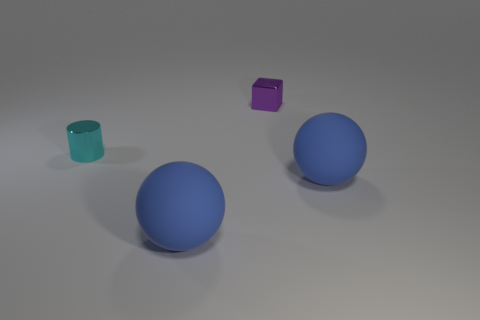Add 2 big matte things. How many objects exist? 6 Subtract all cylinders. How many objects are left? 3 Subtract 1 spheres. How many spheres are left? 1 Subtract all gray spheres. Subtract all brown cylinders. How many spheres are left? 2 Subtract all cyan metallic objects. Subtract all large rubber objects. How many objects are left? 1 Add 4 tiny purple blocks. How many tiny purple blocks are left? 5 Add 3 tiny cyan rubber balls. How many tiny cyan rubber balls exist? 3 Subtract 0 gray cylinders. How many objects are left? 4 